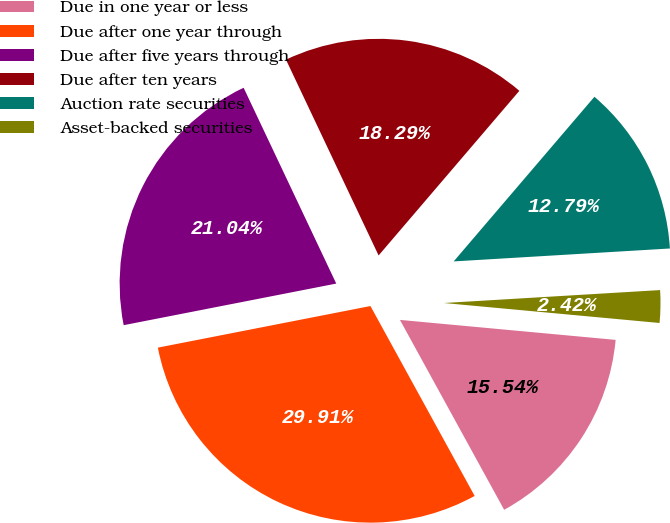Convert chart to OTSL. <chart><loc_0><loc_0><loc_500><loc_500><pie_chart><fcel>Due in one year or less<fcel>Due after one year through<fcel>Due after five years through<fcel>Due after ten years<fcel>Auction rate securities<fcel>Asset-backed securities<nl><fcel>15.54%<fcel>29.91%<fcel>21.04%<fcel>18.29%<fcel>12.79%<fcel>2.42%<nl></chart> 